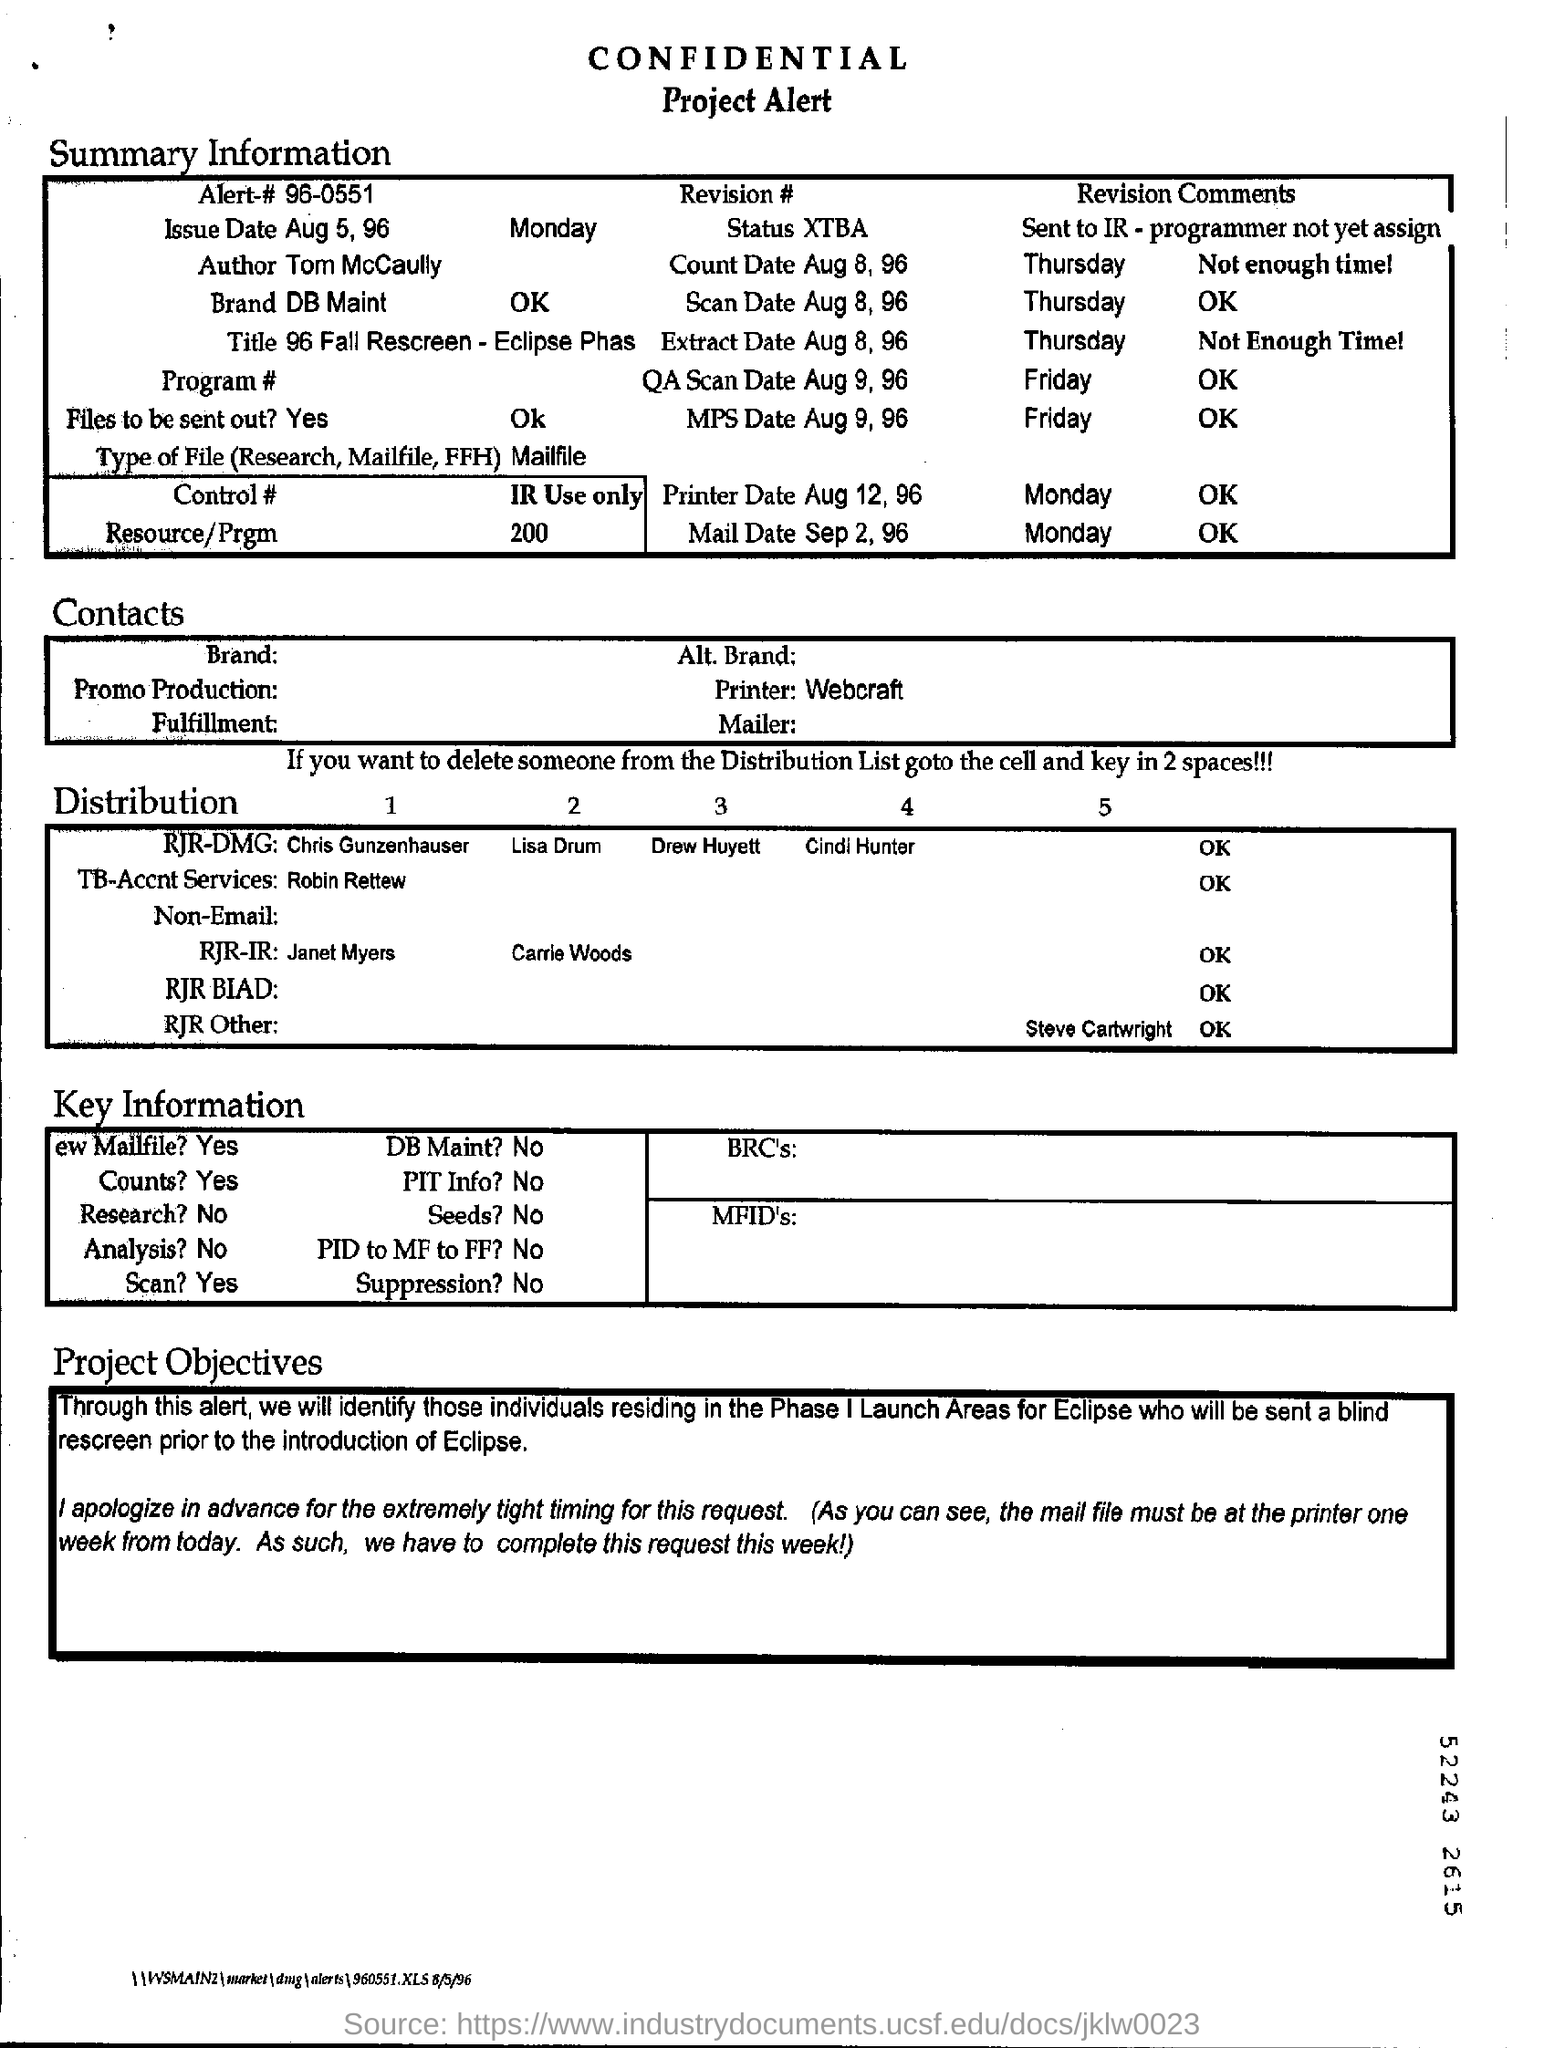Specify some key components in this picture. The printer date is August 12, 1996. The query scan date is August 9, 1996. It is known that the author is Tom McCaully. The count date is August 8, 1996. The message contains the alert number 96-0551. 